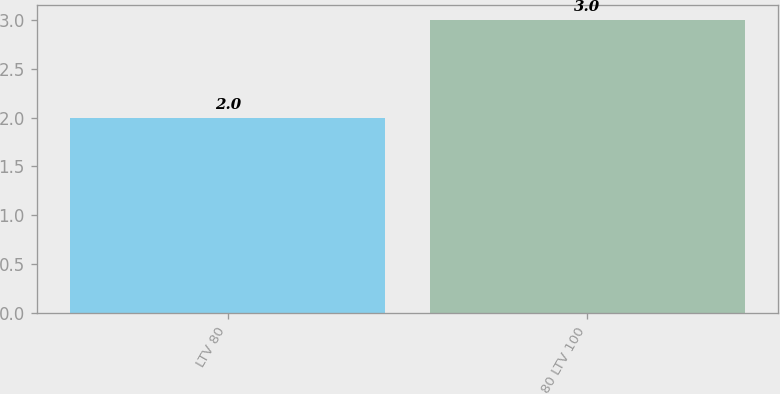Convert chart. <chart><loc_0><loc_0><loc_500><loc_500><bar_chart><fcel>LTV 80<fcel>80 LTV 100<nl><fcel>2<fcel>3<nl></chart> 